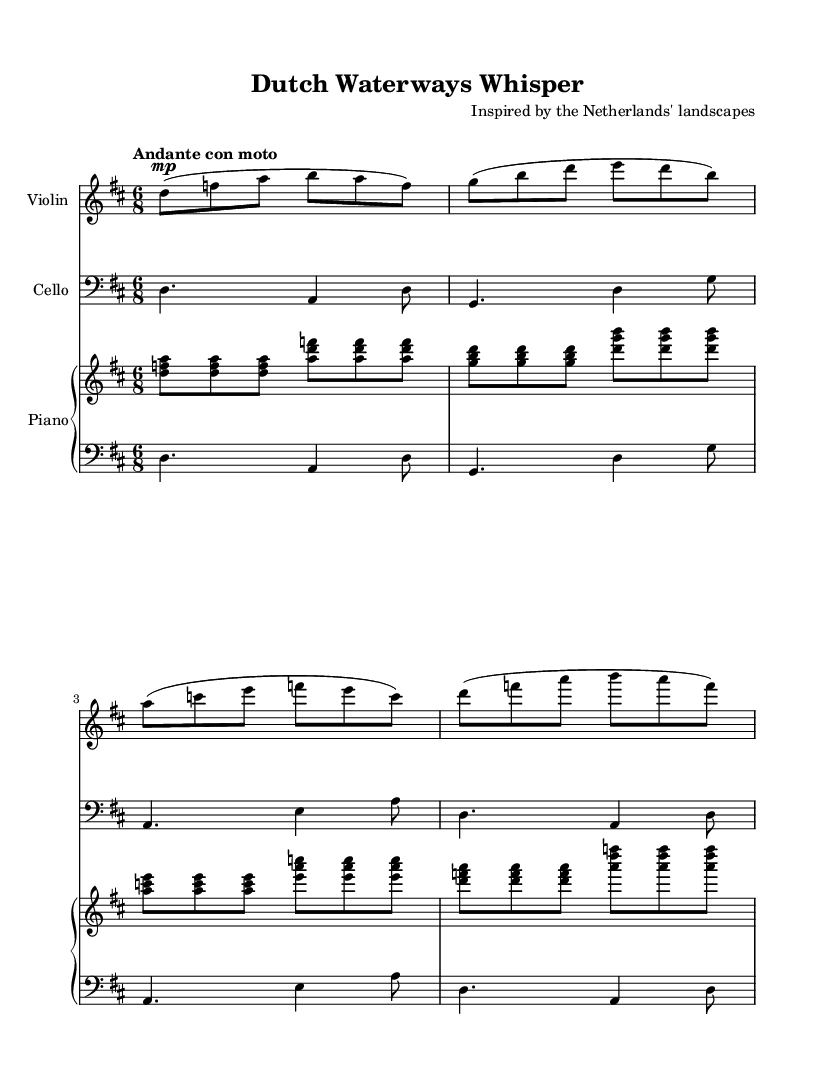What is the key signature of this music? The key signature is D major, which has two sharps (F# and C#). This can be determined by looking at the key signature at the beginning of the staff.
Answer: D major What is the time signature of this music? The time signature is 6/8, indicated at the beginning of the score. This means there are six eighth notes per measure.
Answer: 6/8 What is the tempo marking of this piece? The tempo marking is "Andante con moto," which is indicated at the start of the score. This suggests a moderately slow tempo with a slight movement.
Answer: Andante con moto How many measures are there in the violin part? The violin part has four measures, which can be counted by looking at the notation and bar lines in the staff.
Answer: Four Which instruments are featured in this chamber music piece? The instruments featured are Violin, Cello, and Piano, as indicated at the beginning of each staff in the score.
Answer: Violin, Cello, Piano Describe the character of the music. The character of the music reflects the Romantic era's emotional expressiveness, often seen in the dynamic contrasts and lyrical melodies. This is typical of chamber music's intimate nature, echoing the landscapes of the Netherlands in a sensitive manner.
Answer: Romantic expressiveness 